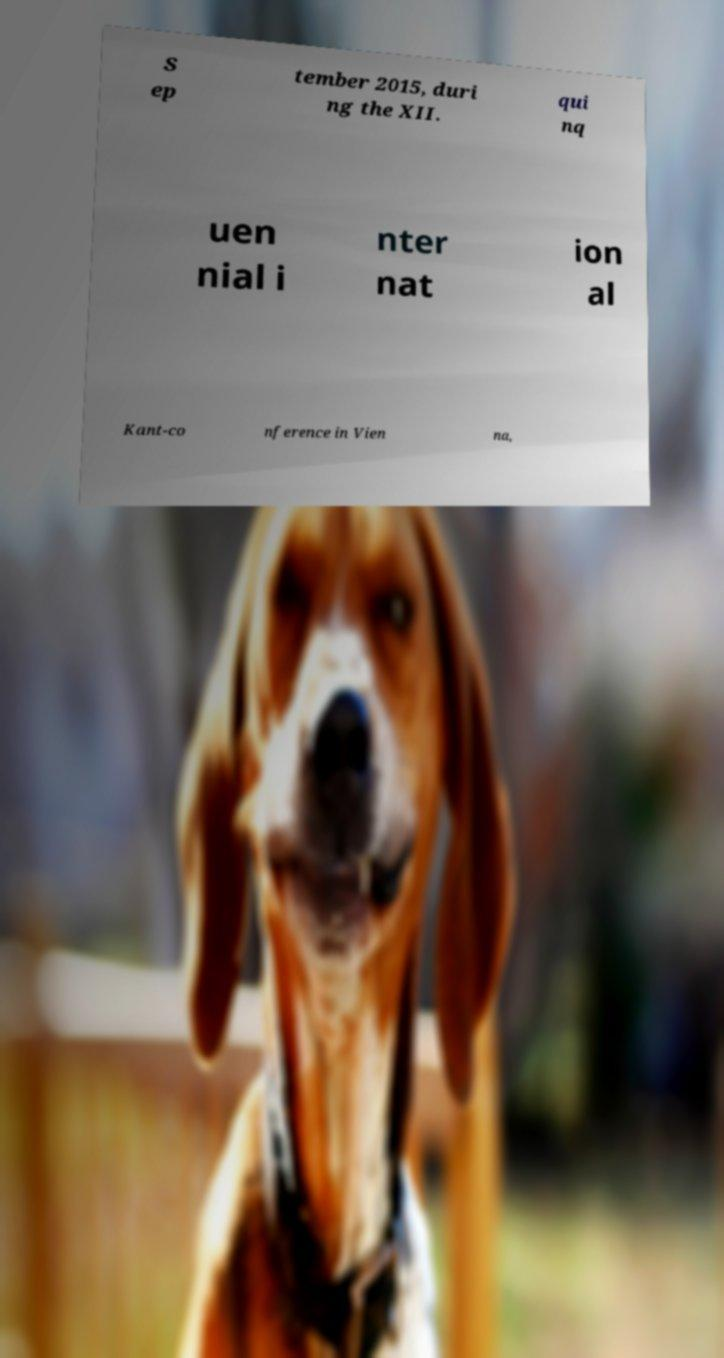Can you read and provide the text displayed in the image?This photo seems to have some interesting text. Can you extract and type it out for me? S ep tember 2015, duri ng the XII. qui nq uen nial i nter nat ion al Kant-co nference in Vien na, 